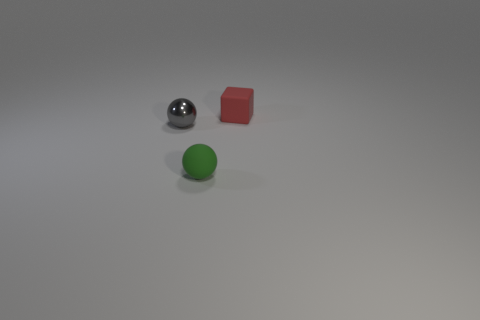There is a object that is on the right side of the gray metal ball and to the left of the tiny red block; what size is it?
Make the answer very short. Small. What number of other things are the same color as the small shiny object?
Offer a terse response. 0. There is a thing that is on the right side of the rubber object that is left of the thing behind the small gray shiny object; what is its size?
Your answer should be very brief. Small. There is a red matte cube; are there any small green matte balls in front of it?
Ensure brevity in your answer.  Yes. Do the green rubber sphere and the object behind the gray metallic thing have the same size?
Make the answer very short. Yes. What number of other objects are the same material as the small gray thing?
Give a very brief answer. 0. There is a tiny thing that is both behind the small rubber ball and in front of the block; what is its shape?
Provide a succinct answer. Sphere. There is a red thing that is the same material as the green thing; what shape is it?
Make the answer very short. Cube. Is there any other thing that is the same shape as the small green rubber object?
Ensure brevity in your answer.  Yes. There is a ball right of the shiny object behind the tiny object in front of the small gray metal thing; what color is it?
Your response must be concise. Green. 